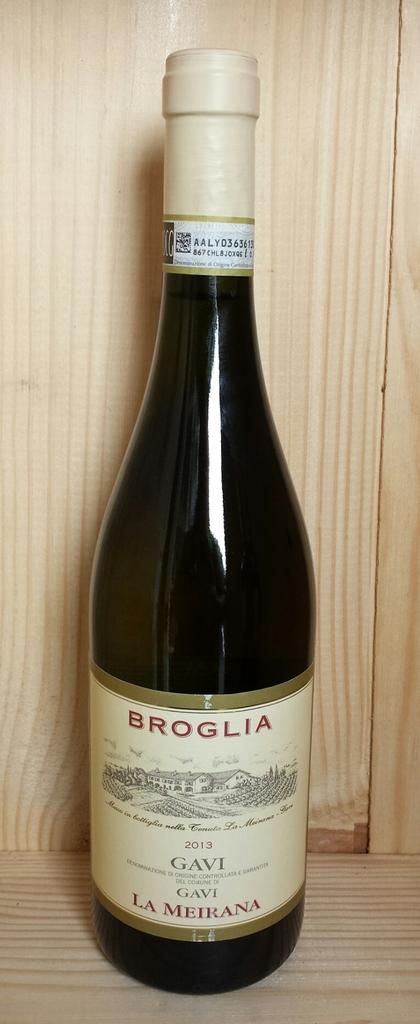What is the name of this wine specifically?
Offer a very short reply. Broglia. 